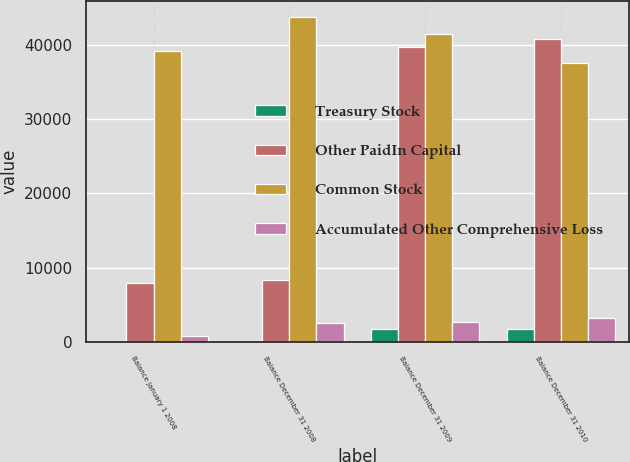<chart> <loc_0><loc_0><loc_500><loc_500><stacked_bar_chart><ecel><fcel>Balance January 1 2008<fcel>Balance December 31 2008<fcel>Balance December 31 2009<fcel>Balance December 31 2010<nl><fcel>Treasury Stock<fcel>30<fcel>30<fcel>1781<fcel>1788<nl><fcel>Other PaidIn Capital<fcel>8014<fcel>8319<fcel>39683<fcel>40701<nl><fcel>Common Stock<fcel>39141<fcel>43699<fcel>41405<fcel>37536<nl><fcel>Accumulated Other Comprehensive Loss<fcel>826<fcel>2554<fcel>2767<fcel>3216<nl></chart> 